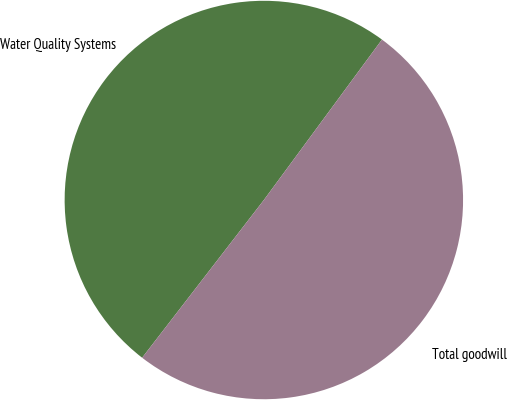Convert chart. <chart><loc_0><loc_0><loc_500><loc_500><pie_chart><fcel>Water Quality Systems<fcel>Total goodwill<nl><fcel>49.64%<fcel>50.36%<nl></chart> 